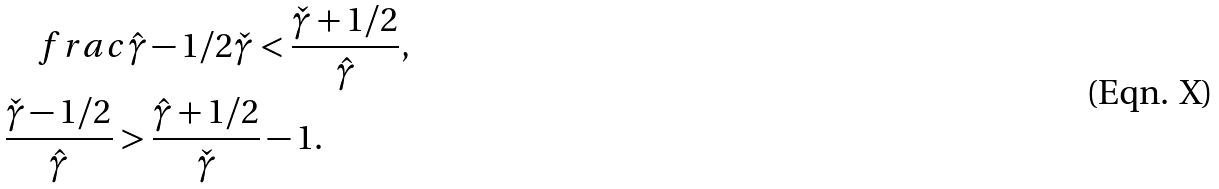Convert formula to latex. <formula><loc_0><loc_0><loc_500><loc_500>& \quad f r a c { \hat { \gamma } - 1 / 2 } { \check { \gamma } } < \frac { \check { \gamma } + 1 / 2 } { \hat { \gamma } } , \\ & \frac { \check { \gamma } - 1 / 2 } { \hat { \gamma } } > \frac { \hat { \gamma } + 1 / 2 } { \check { \gamma } } - 1 .</formula> 